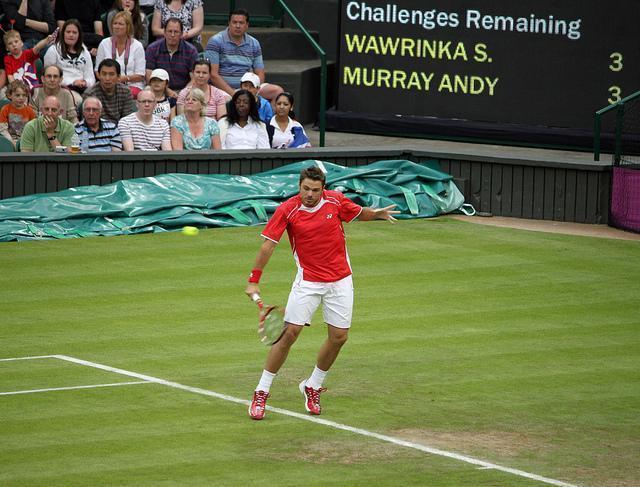What type of sign is shown?
From the following four choices, select the correct answer to address the question.
Options: Scoreboard, warning, brand, regulatory. Scoreboard. 